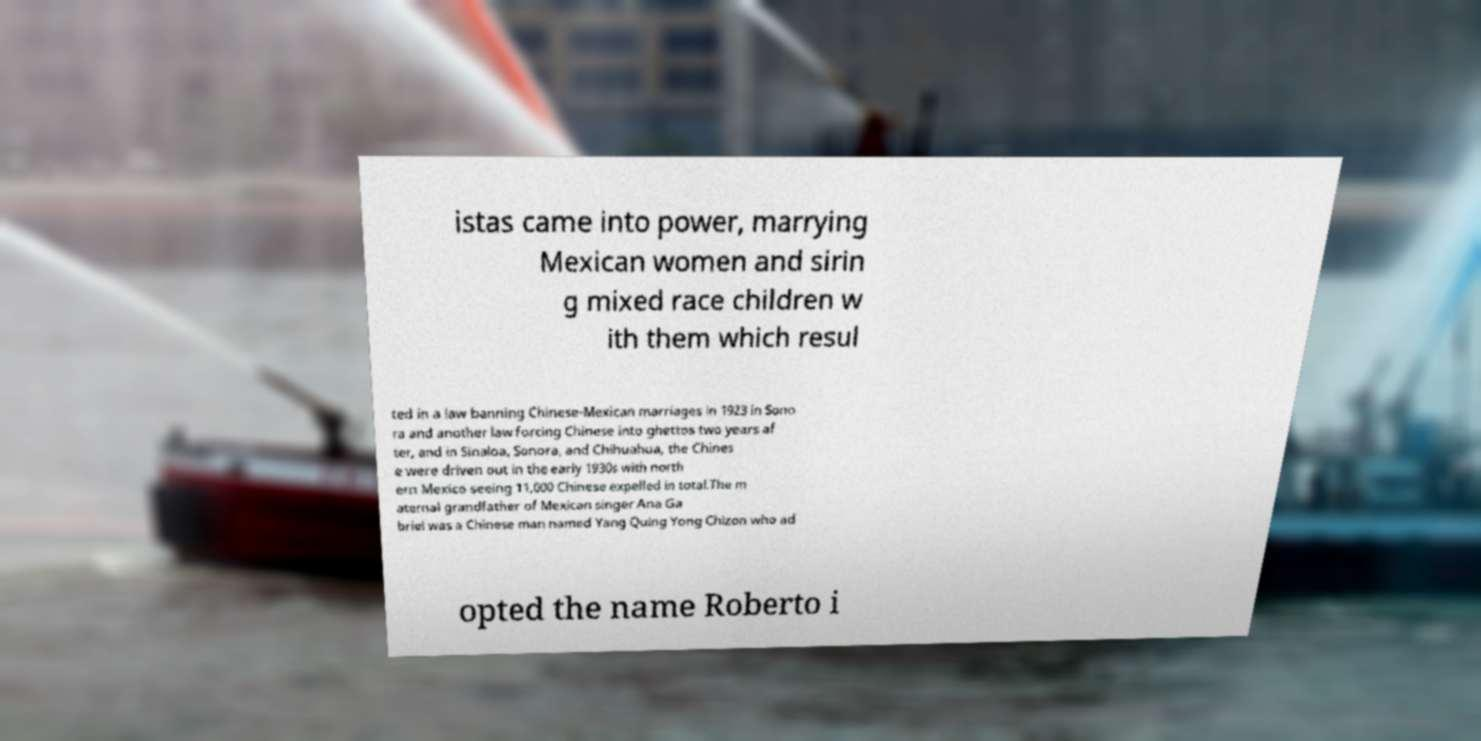I need the written content from this picture converted into text. Can you do that? istas came into power, marrying Mexican women and sirin g mixed race children w ith them which resul ted in a law banning Chinese-Mexican marriages in 1923 in Sono ra and another law forcing Chinese into ghettos two years af ter, and in Sinaloa, Sonora, and Chihuahua, the Chines e were driven out in the early 1930s with north ern Mexico seeing 11,000 Chinese expelled in total.The m aternal grandfather of Mexican singer Ana Ga briel was a Chinese man named Yang Quing Yong Chizon who ad opted the name Roberto i 